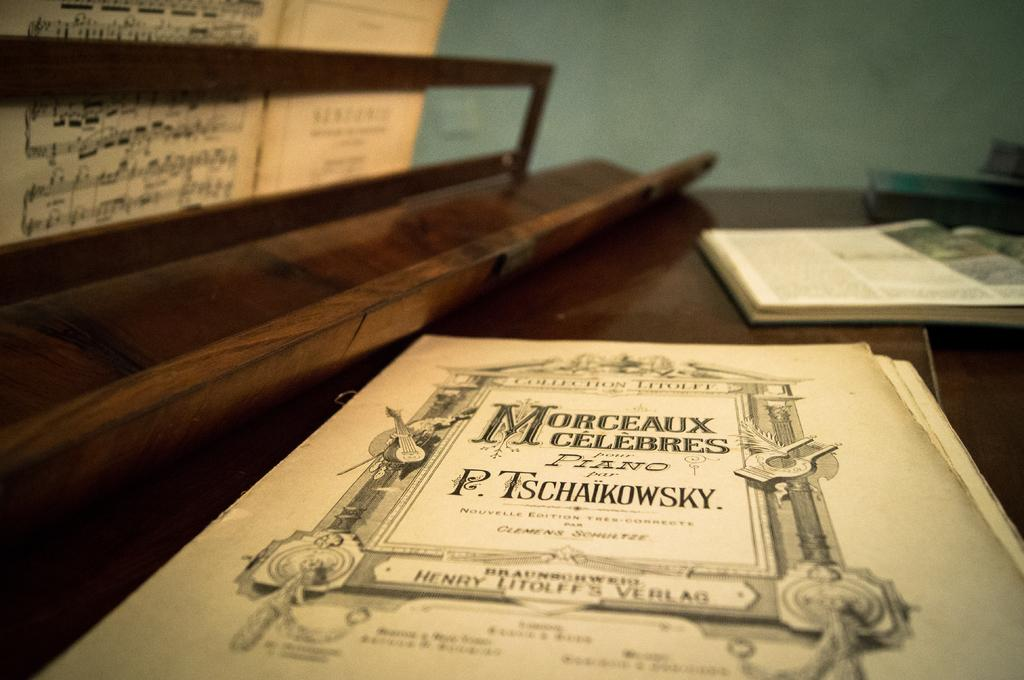Where was the image taken? The image is taken indoors. What can be seen in the image besides the indoor setting? There is a table in the image. What is on the table? There are a few things on the table. What can be seen in the background of the image? There is a wall in the background of the image. What type of farm animals can be seen in the image? There are no farm animals present in the image; it is taken indoors and features a table and a wall in the background. 